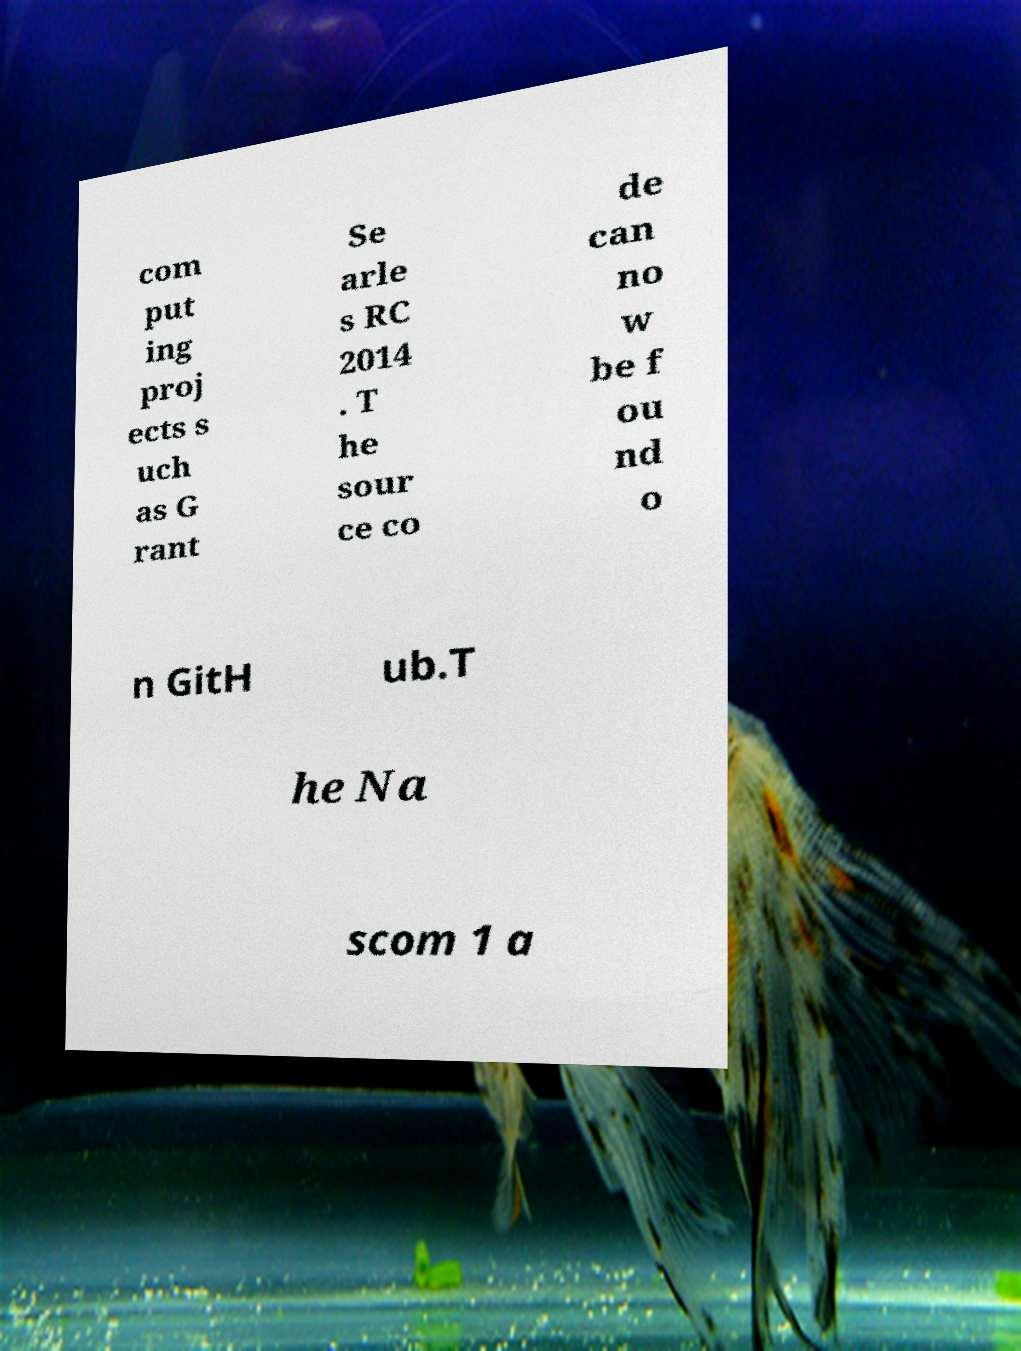What messages or text are displayed in this image? I need them in a readable, typed format. com put ing proj ects s uch as G rant Se arle s RC 2014 . T he sour ce co de can no w be f ou nd o n GitH ub.T he Na scom 1 a 